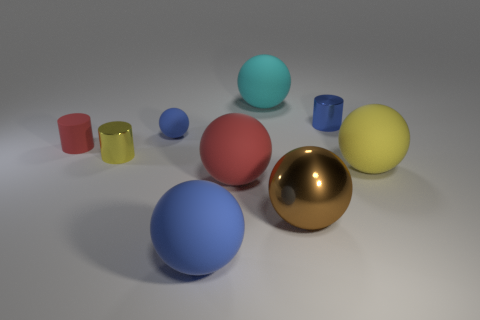Subtract all spheres. How many objects are left? 3 Subtract all brown shiny balls. How many balls are left? 5 Subtract 1 cylinders. How many cylinders are left? 2 Subtract all brown balls. How many balls are left? 5 Subtract all green spheres. Subtract all cyan cylinders. How many spheres are left? 6 Subtract all gray balls. How many blue cylinders are left? 1 Subtract all red cylinders. Subtract all tiny cylinders. How many objects are left? 5 Add 6 large rubber things. How many large rubber things are left? 10 Add 1 large yellow rubber things. How many large yellow rubber things exist? 2 Add 1 gray cylinders. How many objects exist? 10 